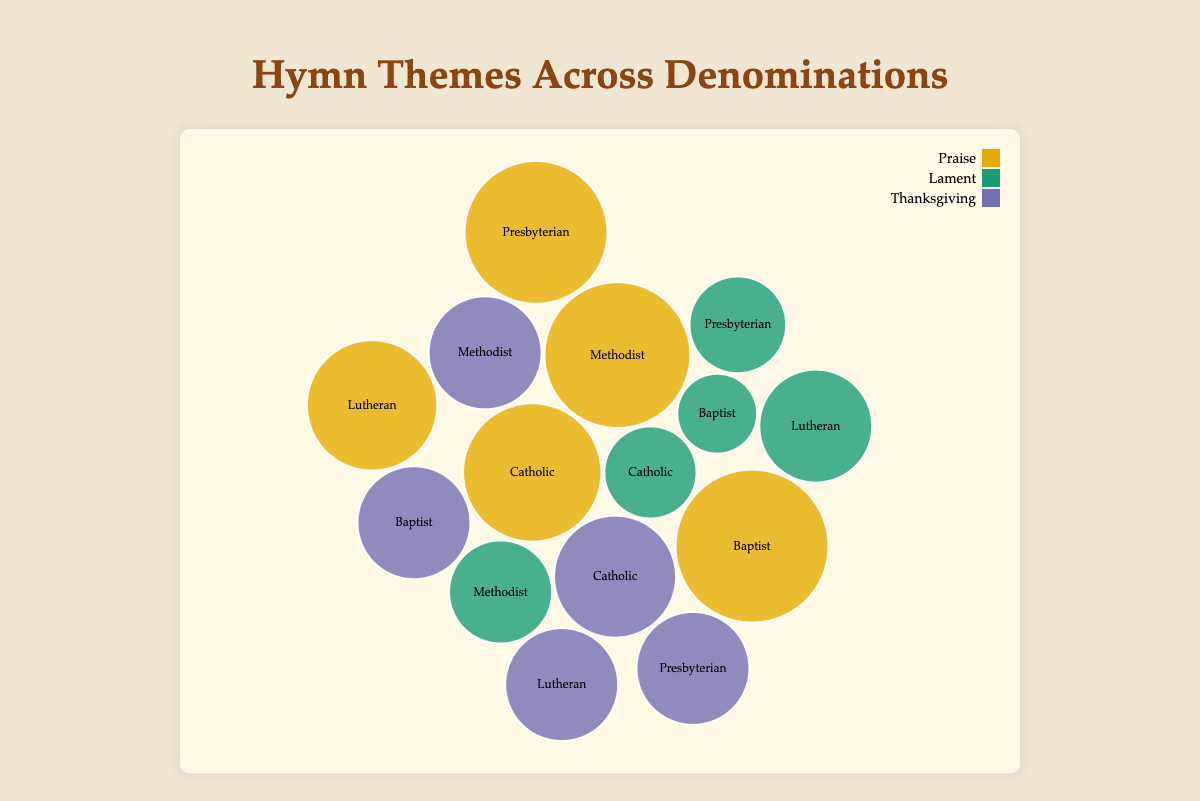What denomination has the highest frequency of Praise hymns? The bubbles representing the Praise theme for each denomination can be compared to find that the Baptist denomination has the highest frequency of Praise hymns at 55.
Answer: Baptist Which theme has the lowest frequency in the Catholic denomination? By comparing the three bubbles representing the Catholic denomination, we can see that Lament has the lowest frequency with 20.
Answer: Lament What is the combined frequency of Thanksgiving hymns across all denominations? Add the frequencies of Thanksgiving hymns for each denomination: 35 (Catholic) + 30 (Methodist) + 30 (Baptist) + 30 (Lutheran) + 30 (Presbyterian) = 155.
Answer: 155 How many themes does the Lutheran denomination have with the same frequency, and what is that frequency? From the plot, it is observed that the Lutheran denomination has three themes with the frequency of 30 each: Lament, Thanksgiving, and Praise.
Answer: Three themes with the frequency of 30 Out of Methodist and Presbyterian, which denomination has a higher frequency of Lament hymns? Compare the bubbles representing Lament for the Methodist and Presbyterian denominations to see that Methodist has a frequency of 25, while Presbyterian has 22. Therefore, Methodist has a higher frequency.
Answer: Methodist What is the total frequency of hymns for the Baptist denomination? Sum the frequencies of all themes for the Baptist denomination: 55 (Praise) + 15 (Lament) + 30 (Thanksgiving) = 100.
Answer: 100 Which denomination has the highest average frequency of hymns across all themes? Calculate the average frequency for each denomination and compare:
Catholic: (45 + 20 + 35)/3 = 33.33
Methodist: (50 + 25 + 30)/3 = 35
Baptist: (55 + 15 + 30)/3 = 33.33
Lutheran: (40 + 30 + 30)/3 = 33.33
Presbyterian: (48 + 22 + 30)/3 = 33.33
Methodist has the highest average frequency with 35.
Answer: Methodist 